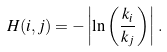<formula> <loc_0><loc_0><loc_500><loc_500>H ( i , j ) = - \left | \ln \left ( \frac { k _ { i } } { k _ { j } } \right ) \right | \, .</formula> 